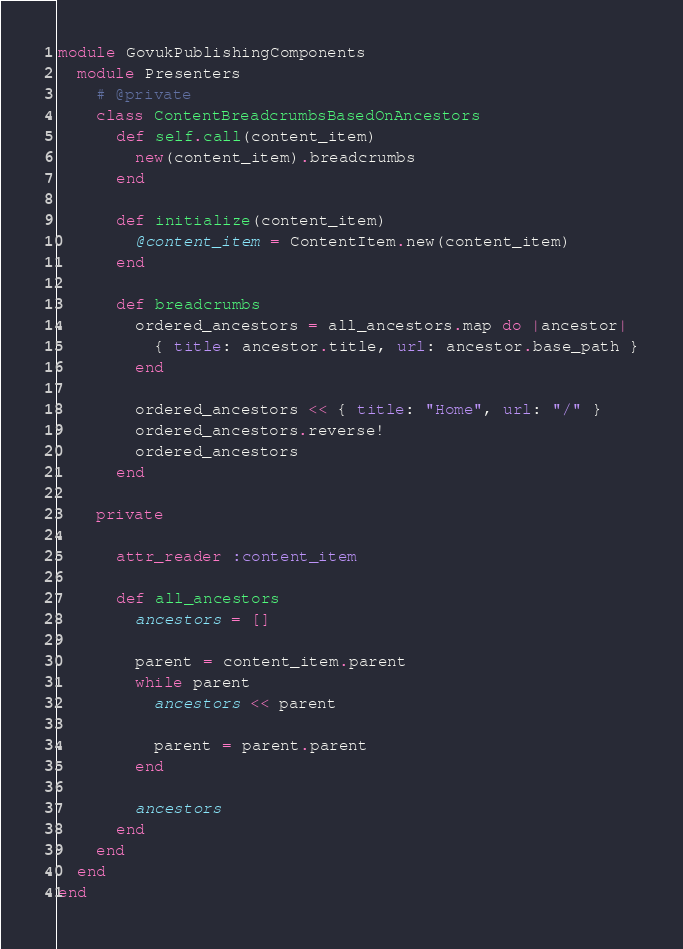<code> <loc_0><loc_0><loc_500><loc_500><_Ruby_>module GovukPublishingComponents
  module Presenters
    # @private
    class ContentBreadcrumbsBasedOnAncestors
      def self.call(content_item)
        new(content_item).breadcrumbs
      end

      def initialize(content_item)
        @content_item = ContentItem.new(content_item)
      end

      def breadcrumbs
        ordered_ancestors = all_ancestors.map do |ancestor|
          { title: ancestor.title, url: ancestor.base_path }
        end

        ordered_ancestors << { title: "Home", url: "/" }
        ordered_ancestors.reverse!
        ordered_ancestors
      end

    private

      attr_reader :content_item

      def all_ancestors
        ancestors = []

        parent = content_item.parent
        while parent
          ancestors << parent

          parent = parent.parent
        end

        ancestors
      end
    end
  end
end
</code> 